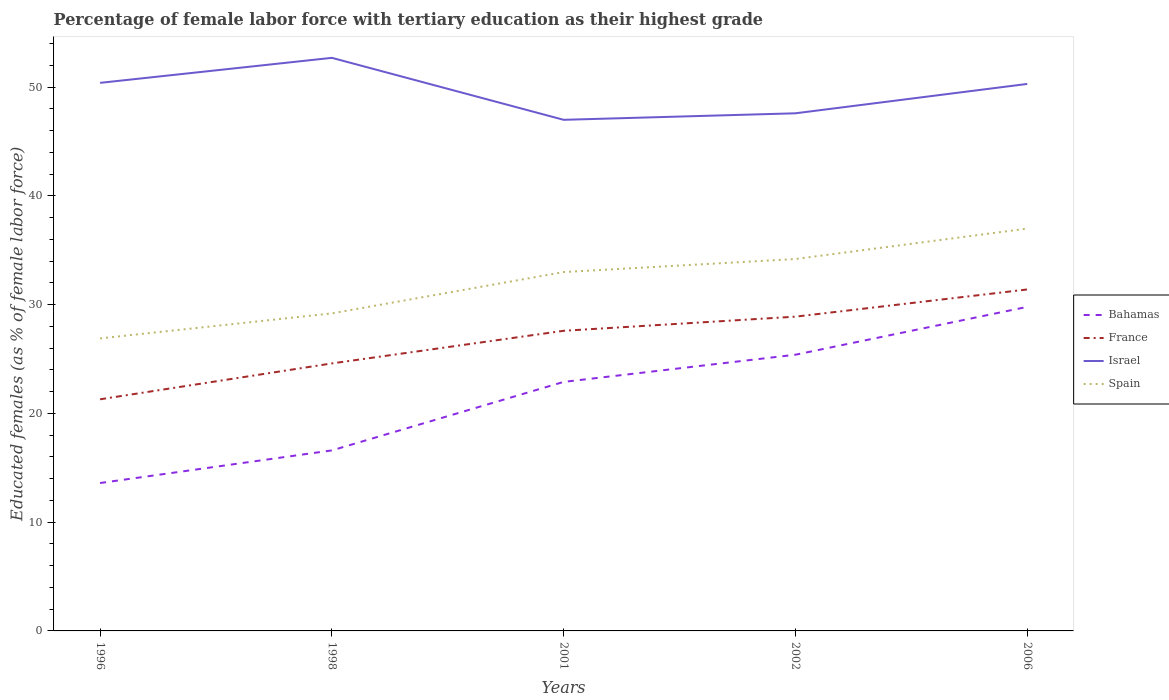Does the line corresponding to France intersect with the line corresponding to Spain?
Give a very brief answer. No. Across all years, what is the maximum percentage of female labor force with tertiary education in Israel?
Make the answer very short. 47. In which year was the percentage of female labor force with tertiary education in Israel maximum?
Offer a terse response. 2001. What is the total percentage of female labor force with tertiary education in Israel in the graph?
Offer a very short reply. -2.3. What is the difference between the highest and the second highest percentage of female labor force with tertiary education in Israel?
Provide a short and direct response. 5.7. What is the difference between the highest and the lowest percentage of female labor force with tertiary education in France?
Give a very brief answer. 3. Is the percentage of female labor force with tertiary education in Spain strictly greater than the percentage of female labor force with tertiary education in Bahamas over the years?
Make the answer very short. No. How many years are there in the graph?
Provide a short and direct response. 5. Are the values on the major ticks of Y-axis written in scientific E-notation?
Your answer should be compact. No. Does the graph contain any zero values?
Offer a terse response. No. Does the graph contain grids?
Provide a short and direct response. No. Where does the legend appear in the graph?
Ensure brevity in your answer.  Center right. How are the legend labels stacked?
Keep it short and to the point. Vertical. What is the title of the graph?
Your answer should be very brief. Percentage of female labor force with tertiary education as their highest grade. What is the label or title of the X-axis?
Keep it short and to the point. Years. What is the label or title of the Y-axis?
Offer a terse response. Educated females (as % of female labor force). What is the Educated females (as % of female labor force) of Bahamas in 1996?
Provide a short and direct response. 13.6. What is the Educated females (as % of female labor force) of France in 1996?
Your answer should be very brief. 21.3. What is the Educated females (as % of female labor force) in Israel in 1996?
Provide a succinct answer. 50.4. What is the Educated females (as % of female labor force) in Spain in 1996?
Keep it short and to the point. 26.9. What is the Educated females (as % of female labor force) in Bahamas in 1998?
Provide a short and direct response. 16.6. What is the Educated females (as % of female labor force) in France in 1998?
Offer a very short reply. 24.6. What is the Educated females (as % of female labor force) in Israel in 1998?
Make the answer very short. 52.7. What is the Educated females (as % of female labor force) of Spain in 1998?
Your answer should be very brief. 29.2. What is the Educated females (as % of female labor force) of Bahamas in 2001?
Offer a terse response. 22.9. What is the Educated females (as % of female labor force) of France in 2001?
Your answer should be very brief. 27.6. What is the Educated females (as % of female labor force) in Bahamas in 2002?
Provide a short and direct response. 25.4. What is the Educated females (as % of female labor force) in France in 2002?
Provide a short and direct response. 28.9. What is the Educated females (as % of female labor force) of Israel in 2002?
Ensure brevity in your answer.  47.6. What is the Educated females (as % of female labor force) in Spain in 2002?
Keep it short and to the point. 34.2. What is the Educated females (as % of female labor force) of Bahamas in 2006?
Offer a very short reply. 29.8. What is the Educated females (as % of female labor force) of France in 2006?
Your answer should be compact. 31.4. What is the Educated females (as % of female labor force) in Israel in 2006?
Ensure brevity in your answer.  50.3. What is the Educated females (as % of female labor force) in Spain in 2006?
Your answer should be compact. 37. Across all years, what is the maximum Educated females (as % of female labor force) of Bahamas?
Give a very brief answer. 29.8. Across all years, what is the maximum Educated females (as % of female labor force) in France?
Offer a terse response. 31.4. Across all years, what is the maximum Educated females (as % of female labor force) of Israel?
Give a very brief answer. 52.7. Across all years, what is the maximum Educated females (as % of female labor force) in Spain?
Make the answer very short. 37. Across all years, what is the minimum Educated females (as % of female labor force) of Bahamas?
Your answer should be very brief. 13.6. Across all years, what is the minimum Educated females (as % of female labor force) of France?
Your answer should be very brief. 21.3. Across all years, what is the minimum Educated females (as % of female labor force) of Israel?
Offer a very short reply. 47. Across all years, what is the minimum Educated females (as % of female labor force) in Spain?
Make the answer very short. 26.9. What is the total Educated females (as % of female labor force) of Bahamas in the graph?
Keep it short and to the point. 108.3. What is the total Educated females (as % of female labor force) of France in the graph?
Your answer should be compact. 133.8. What is the total Educated females (as % of female labor force) of Israel in the graph?
Your response must be concise. 248. What is the total Educated females (as % of female labor force) of Spain in the graph?
Make the answer very short. 160.3. What is the difference between the Educated females (as % of female labor force) of Israel in 1996 and that in 1998?
Provide a short and direct response. -2.3. What is the difference between the Educated females (as % of female labor force) in Spain in 1996 and that in 1998?
Keep it short and to the point. -2.3. What is the difference between the Educated females (as % of female labor force) of Bahamas in 1996 and that in 2001?
Provide a short and direct response. -9.3. What is the difference between the Educated females (as % of female labor force) of France in 1996 and that in 2001?
Your response must be concise. -6.3. What is the difference between the Educated females (as % of female labor force) of Spain in 1996 and that in 2001?
Provide a short and direct response. -6.1. What is the difference between the Educated females (as % of female labor force) in Bahamas in 1996 and that in 2006?
Your answer should be very brief. -16.2. What is the difference between the Educated females (as % of female labor force) of Israel in 1996 and that in 2006?
Keep it short and to the point. 0.1. What is the difference between the Educated females (as % of female labor force) in Spain in 1996 and that in 2006?
Your answer should be compact. -10.1. What is the difference between the Educated females (as % of female labor force) of Bahamas in 1998 and that in 2001?
Offer a terse response. -6.3. What is the difference between the Educated females (as % of female labor force) of France in 1998 and that in 2001?
Give a very brief answer. -3. What is the difference between the Educated females (as % of female labor force) of Spain in 1998 and that in 2001?
Keep it short and to the point. -3.8. What is the difference between the Educated females (as % of female labor force) of Bahamas in 1998 and that in 2002?
Your answer should be very brief. -8.8. What is the difference between the Educated females (as % of female labor force) in France in 1998 and that in 2002?
Your answer should be compact. -4.3. What is the difference between the Educated females (as % of female labor force) of Israel in 1998 and that in 2002?
Keep it short and to the point. 5.1. What is the difference between the Educated females (as % of female labor force) in Spain in 1998 and that in 2006?
Your answer should be compact. -7.8. What is the difference between the Educated females (as % of female labor force) of France in 2001 and that in 2002?
Keep it short and to the point. -1.3. What is the difference between the Educated females (as % of female labor force) of Israel in 2001 and that in 2002?
Ensure brevity in your answer.  -0.6. What is the difference between the Educated females (as % of female labor force) in Israel in 2001 and that in 2006?
Keep it short and to the point. -3.3. What is the difference between the Educated females (as % of female labor force) in Bahamas in 2002 and that in 2006?
Your response must be concise. -4.4. What is the difference between the Educated females (as % of female labor force) of Spain in 2002 and that in 2006?
Provide a succinct answer. -2.8. What is the difference between the Educated females (as % of female labor force) of Bahamas in 1996 and the Educated females (as % of female labor force) of Israel in 1998?
Provide a succinct answer. -39.1. What is the difference between the Educated females (as % of female labor force) in Bahamas in 1996 and the Educated females (as % of female labor force) in Spain in 1998?
Provide a short and direct response. -15.6. What is the difference between the Educated females (as % of female labor force) of France in 1996 and the Educated females (as % of female labor force) of Israel in 1998?
Ensure brevity in your answer.  -31.4. What is the difference between the Educated females (as % of female labor force) in France in 1996 and the Educated females (as % of female labor force) in Spain in 1998?
Offer a terse response. -7.9. What is the difference between the Educated females (as % of female labor force) in Israel in 1996 and the Educated females (as % of female labor force) in Spain in 1998?
Make the answer very short. 21.2. What is the difference between the Educated females (as % of female labor force) in Bahamas in 1996 and the Educated females (as % of female labor force) in Israel in 2001?
Ensure brevity in your answer.  -33.4. What is the difference between the Educated females (as % of female labor force) of Bahamas in 1996 and the Educated females (as % of female labor force) of Spain in 2001?
Your answer should be very brief. -19.4. What is the difference between the Educated females (as % of female labor force) in France in 1996 and the Educated females (as % of female labor force) in Israel in 2001?
Ensure brevity in your answer.  -25.7. What is the difference between the Educated females (as % of female labor force) of France in 1996 and the Educated females (as % of female labor force) of Spain in 2001?
Offer a very short reply. -11.7. What is the difference between the Educated females (as % of female labor force) of Israel in 1996 and the Educated females (as % of female labor force) of Spain in 2001?
Offer a terse response. 17.4. What is the difference between the Educated females (as % of female labor force) of Bahamas in 1996 and the Educated females (as % of female labor force) of France in 2002?
Keep it short and to the point. -15.3. What is the difference between the Educated females (as % of female labor force) of Bahamas in 1996 and the Educated females (as % of female labor force) of Israel in 2002?
Offer a very short reply. -34. What is the difference between the Educated females (as % of female labor force) in Bahamas in 1996 and the Educated females (as % of female labor force) in Spain in 2002?
Offer a very short reply. -20.6. What is the difference between the Educated females (as % of female labor force) of France in 1996 and the Educated females (as % of female labor force) of Israel in 2002?
Your answer should be compact. -26.3. What is the difference between the Educated females (as % of female labor force) in France in 1996 and the Educated females (as % of female labor force) in Spain in 2002?
Your answer should be compact. -12.9. What is the difference between the Educated females (as % of female labor force) of Bahamas in 1996 and the Educated females (as % of female labor force) of France in 2006?
Your answer should be very brief. -17.8. What is the difference between the Educated females (as % of female labor force) in Bahamas in 1996 and the Educated females (as % of female labor force) in Israel in 2006?
Provide a succinct answer. -36.7. What is the difference between the Educated females (as % of female labor force) of Bahamas in 1996 and the Educated females (as % of female labor force) of Spain in 2006?
Provide a succinct answer. -23.4. What is the difference between the Educated females (as % of female labor force) of France in 1996 and the Educated females (as % of female labor force) of Spain in 2006?
Provide a succinct answer. -15.7. What is the difference between the Educated females (as % of female labor force) of Bahamas in 1998 and the Educated females (as % of female labor force) of France in 2001?
Make the answer very short. -11. What is the difference between the Educated females (as % of female labor force) of Bahamas in 1998 and the Educated females (as % of female labor force) of Israel in 2001?
Keep it short and to the point. -30.4. What is the difference between the Educated females (as % of female labor force) in Bahamas in 1998 and the Educated females (as % of female labor force) in Spain in 2001?
Provide a short and direct response. -16.4. What is the difference between the Educated females (as % of female labor force) of France in 1998 and the Educated females (as % of female labor force) of Israel in 2001?
Your answer should be compact. -22.4. What is the difference between the Educated females (as % of female labor force) in Israel in 1998 and the Educated females (as % of female labor force) in Spain in 2001?
Make the answer very short. 19.7. What is the difference between the Educated females (as % of female labor force) in Bahamas in 1998 and the Educated females (as % of female labor force) in France in 2002?
Make the answer very short. -12.3. What is the difference between the Educated females (as % of female labor force) in Bahamas in 1998 and the Educated females (as % of female labor force) in Israel in 2002?
Offer a very short reply. -31. What is the difference between the Educated females (as % of female labor force) of Bahamas in 1998 and the Educated females (as % of female labor force) of Spain in 2002?
Your answer should be very brief. -17.6. What is the difference between the Educated females (as % of female labor force) in France in 1998 and the Educated females (as % of female labor force) in Israel in 2002?
Ensure brevity in your answer.  -23. What is the difference between the Educated females (as % of female labor force) of Bahamas in 1998 and the Educated females (as % of female labor force) of France in 2006?
Provide a succinct answer. -14.8. What is the difference between the Educated females (as % of female labor force) of Bahamas in 1998 and the Educated females (as % of female labor force) of Israel in 2006?
Offer a terse response. -33.7. What is the difference between the Educated females (as % of female labor force) in Bahamas in 1998 and the Educated females (as % of female labor force) in Spain in 2006?
Offer a terse response. -20.4. What is the difference between the Educated females (as % of female labor force) in France in 1998 and the Educated females (as % of female labor force) in Israel in 2006?
Make the answer very short. -25.7. What is the difference between the Educated females (as % of female labor force) of Israel in 1998 and the Educated females (as % of female labor force) of Spain in 2006?
Offer a terse response. 15.7. What is the difference between the Educated females (as % of female labor force) in Bahamas in 2001 and the Educated females (as % of female labor force) in Israel in 2002?
Ensure brevity in your answer.  -24.7. What is the difference between the Educated females (as % of female labor force) in France in 2001 and the Educated females (as % of female labor force) in Israel in 2002?
Ensure brevity in your answer.  -20. What is the difference between the Educated females (as % of female labor force) in Bahamas in 2001 and the Educated females (as % of female labor force) in France in 2006?
Your answer should be very brief. -8.5. What is the difference between the Educated females (as % of female labor force) in Bahamas in 2001 and the Educated females (as % of female labor force) in Israel in 2006?
Provide a short and direct response. -27.4. What is the difference between the Educated females (as % of female labor force) of Bahamas in 2001 and the Educated females (as % of female labor force) of Spain in 2006?
Offer a very short reply. -14.1. What is the difference between the Educated females (as % of female labor force) of France in 2001 and the Educated females (as % of female labor force) of Israel in 2006?
Make the answer very short. -22.7. What is the difference between the Educated females (as % of female labor force) of Bahamas in 2002 and the Educated females (as % of female labor force) of Israel in 2006?
Give a very brief answer. -24.9. What is the difference between the Educated females (as % of female labor force) of France in 2002 and the Educated females (as % of female labor force) of Israel in 2006?
Ensure brevity in your answer.  -21.4. What is the difference between the Educated females (as % of female labor force) of France in 2002 and the Educated females (as % of female labor force) of Spain in 2006?
Offer a very short reply. -8.1. What is the average Educated females (as % of female labor force) of Bahamas per year?
Your response must be concise. 21.66. What is the average Educated females (as % of female labor force) in France per year?
Your answer should be compact. 26.76. What is the average Educated females (as % of female labor force) in Israel per year?
Provide a short and direct response. 49.6. What is the average Educated females (as % of female labor force) of Spain per year?
Ensure brevity in your answer.  32.06. In the year 1996, what is the difference between the Educated females (as % of female labor force) of Bahamas and Educated females (as % of female labor force) of France?
Provide a succinct answer. -7.7. In the year 1996, what is the difference between the Educated females (as % of female labor force) of Bahamas and Educated females (as % of female labor force) of Israel?
Keep it short and to the point. -36.8. In the year 1996, what is the difference between the Educated females (as % of female labor force) in France and Educated females (as % of female labor force) in Israel?
Make the answer very short. -29.1. In the year 1996, what is the difference between the Educated females (as % of female labor force) of France and Educated females (as % of female labor force) of Spain?
Your response must be concise. -5.6. In the year 1996, what is the difference between the Educated females (as % of female labor force) of Israel and Educated females (as % of female labor force) of Spain?
Offer a terse response. 23.5. In the year 1998, what is the difference between the Educated females (as % of female labor force) in Bahamas and Educated females (as % of female labor force) in France?
Your answer should be compact. -8. In the year 1998, what is the difference between the Educated females (as % of female labor force) in Bahamas and Educated females (as % of female labor force) in Israel?
Give a very brief answer. -36.1. In the year 1998, what is the difference between the Educated females (as % of female labor force) of Bahamas and Educated females (as % of female labor force) of Spain?
Give a very brief answer. -12.6. In the year 1998, what is the difference between the Educated females (as % of female labor force) in France and Educated females (as % of female labor force) in Israel?
Your response must be concise. -28.1. In the year 1998, what is the difference between the Educated females (as % of female labor force) of France and Educated females (as % of female labor force) of Spain?
Ensure brevity in your answer.  -4.6. In the year 2001, what is the difference between the Educated females (as % of female labor force) of Bahamas and Educated females (as % of female labor force) of France?
Ensure brevity in your answer.  -4.7. In the year 2001, what is the difference between the Educated females (as % of female labor force) in Bahamas and Educated females (as % of female labor force) in Israel?
Your response must be concise. -24.1. In the year 2001, what is the difference between the Educated females (as % of female labor force) of France and Educated females (as % of female labor force) of Israel?
Make the answer very short. -19.4. In the year 2001, what is the difference between the Educated females (as % of female labor force) of France and Educated females (as % of female labor force) of Spain?
Your answer should be compact. -5.4. In the year 2001, what is the difference between the Educated females (as % of female labor force) of Israel and Educated females (as % of female labor force) of Spain?
Your response must be concise. 14. In the year 2002, what is the difference between the Educated females (as % of female labor force) in Bahamas and Educated females (as % of female labor force) in France?
Provide a short and direct response. -3.5. In the year 2002, what is the difference between the Educated females (as % of female labor force) of Bahamas and Educated females (as % of female labor force) of Israel?
Your answer should be compact. -22.2. In the year 2002, what is the difference between the Educated females (as % of female labor force) of France and Educated females (as % of female labor force) of Israel?
Make the answer very short. -18.7. In the year 2002, what is the difference between the Educated females (as % of female labor force) in France and Educated females (as % of female labor force) in Spain?
Offer a terse response. -5.3. In the year 2002, what is the difference between the Educated females (as % of female labor force) in Israel and Educated females (as % of female labor force) in Spain?
Your response must be concise. 13.4. In the year 2006, what is the difference between the Educated females (as % of female labor force) of Bahamas and Educated females (as % of female labor force) of France?
Your answer should be compact. -1.6. In the year 2006, what is the difference between the Educated females (as % of female labor force) in Bahamas and Educated females (as % of female labor force) in Israel?
Give a very brief answer. -20.5. In the year 2006, what is the difference between the Educated females (as % of female labor force) of France and Educated females (as % of female labor force) of Israel?
Your answer should be compact. -18.9. In the year 2006, what is the difference between the Educated females (as % of female labor force) in France and Educated females (as % of female labor force) in Spain?
Your answer should be very brief. -5.6. What is the ratio of the Educated females (as % of female labor force) in Bahamas in 1996 to that in 1998?
Give a very brief answer. 0.82. What is the ratio of the Educated females (as % of female labor force) in France in 1996 to that in 1998?
Ensure brevity in your answer.  0.87. What is the ratio of the Educated females (as % of female labor force) in Israel in 1996 to that in 1998?
Provide a short and direct response. 0.96. What is the ratio of the Educated females (as % of female labor force) in Spain in 1996 to that in 1998?
Make the answer very short. 0.92. What is the ratio of the Educated females (as % of female labor force) of Bahamas in 1996 to that in 2001?
Offer a terse response. 0.59. What is the ratio of the Educated females (as % of female labor force) in France in 1996 to that in 2001?
Keep it short and to the point. 0.77. What is the ratio of the Educated females (as % of female labor force) in Israel in 1996 to that in 2001?
Ensure brevity in your answer.  1.07. What is the ratio of the Educated females (as % of female labor force) in Spain in 1996 to that in 2001?
Your answer should be compact. 0.82. What is the ratio of the Educated females (as % of female labor force) in Bahamas in 1996 to that in 2002?
Your response must be concise. 0.54. What is the ratio of the Educated females (as % of female labor force) in France in 1996 to that in 2002?
Your answer should be compact. 0.74. What is the ratio of the Educated females (as % of female labor force) of Israel in 1996 to that in 2002?
Provide a succinct answer. 1.06. What is the ratio of the Educated females (as % of female labor force) of Spain in 1996 to that in 2002?
Provide a succinct answer. 0.79. What is the ratio of the Educated females (as % of female labor force) of Bahamas in 1996 to that in 2006?
Offer a very short reply. 0.46. What is the ratio of the Educated females (as % of female labor force) of France in 1996 to that in 2006?
Your response must be concise. 0.68. What is the ratio of the Educated females (as % of female labor force) in Israel in 1996 to that in 2006?
Your response must be concise. 1. What is the ratio of the Educated females (as % of female labor force) in Spain in 1996 to that in 2006?
Make the answer very short. 0.73. What is the ratio of the Educated females (as % of female labor force) in Bahamas in 1998 to that in 2001?
Offer a terse response. 0.72. What is the ratio of the Educated females (as % of female labor force) in France in 1998 to that in 2001?
Your response must be concise. 0.89. What is the ratio of the Educated females (as % of female labor force) in Israel in 1998 to that in 2001?
Your answer should be very brief. 1.12. What is the ratio of the Educated females (as % of female labor force) in Spain in 1998 to that in 2001?
Offer a very short reply. 0.88. What is the ratio of the Educated females (as % of female labor force) of Bahamas in 1998 to that in 2002?
Your answer should be very brief. 0.65. What is the ratio of the Educated females (as % of female labor force) in France in 1998 to that in 2002?
Make the answer very short. 0.85. What is the ratio of the Educated females (as % of female labor force) of Israel in 1998 to that in 2002?
Provide a short and direct response. 1.11. What is the ratio of the Educated females (as % of female labor force) of Spain in 1998 to that in 2002?
Make the answer very short. 0.85. What is the ratio of the Educated females (as % of female labor force) of Bahamas in 1998 to that in 2006?
Provide a short and direct response. 0.56. What is the ratio of the Educated females (as % of female labor force) in France in 1998 to that in 2006?
Provide a short and direct response. 0.78. What is the ratio of the Educated females (as % of female labor force) of Israel in 1998 to that in 2006?
Provide a succinct answer. 1.05. What is the ratio of the Educated females (as % of female labor force) in Spain in 1998 to that in 2006?
Give a very brief answer. 0.79. What is the ratio of the Educated females (as % of female labor force) of Bahamas in 2001 to that in 2002?
Offer a terse response. 0.9. What is the ratio of the Educated females (as % of female labor force) in France in 2001 to that in 2002?
Ensure brevity in your answer.  0.95. What is the ratio of the Educated females (as % of female labor force) in Israel in 2001 to that in 2002?
Provide a succinct answer. 0.99. What is the ratio of the Educated females (as % of female labor force) of Spain in 2001 to that in 2002?
Your response must be concise. 0.96. What is the ratio of the Educated females (as % of female labor force) in Bahamas in 2001 to that in 2006?
Provide a succinct answer. 0.77. What is the ratio of the Educated females (as % of female labor force) in France in 2001 to that in 2006?
Provide a short and direct response. 0.88. What is the ratio of the Educated females (as % of female labor force) of Israel in 2001 to that in 2006?
Provide a short and direct response. 0.93. What is the ratio of the Educated females (as % of female labor force) of Spain in 2001 to that in 2006?
Make the answer very short. 0.89. What is the ratio of the Educated females (as % of female labor force) of Bahamas in 2002 to that in 2006?
Your answer should be compact. 0.85. What is the ratio of the Educated females (as % of female labor force) in France in 2002 to that in 2006?
Offer a terse response. 0.92. What is the ratio of the Educated females (as % of female labor force) of Israel in 2002 to that in 2006?
Your response must be concise. 0.95. What is the ratio of the Educated females (as % of female labor force) in Spain in 2002 to that in 2006?
Make the answer very short. 0.92. What is the difference between the highest and the lowest Educated females (as % of female labor force) in France?
Offer a very short reply. 10.1. What is the difference between the highest and the lowest Educated females (as % of female labor force) of Israel?
Your answer should be very brief. 5.7. What is the difference between the highest and the lowest Educated females (as % of female labor force) in Spain?
Offer a very short reply. 10.1. 